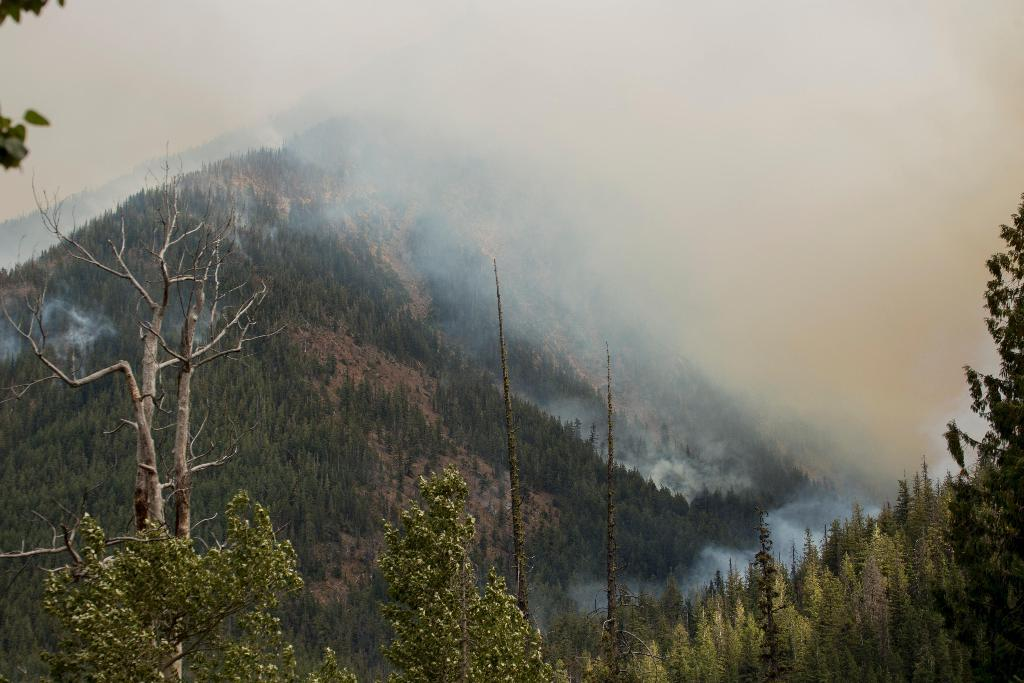What type of vegetation can be seen in the image? There are trees in the image. What geographical features are present in the image? There are hills in the image. What atmospheric condition can be observed in the background? There is fog in the background of the image. What type of paper is visible in the image? There is no paper present in the image. Is there a pipe visible in the image? There is no pipe present in the image. 